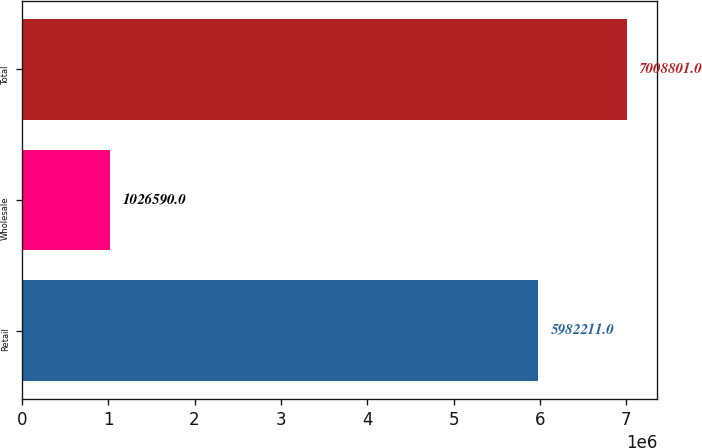Convert chart. <chart><loc_0><loc_0><loc_500><loc_500><bar_chart><fcel>Retail<fcel>Wholesale<fcel>Total<nl><fcel>5.98221e+06<fcel>1.02659e+06<fcel>7.0088e+06<nl></chart> 